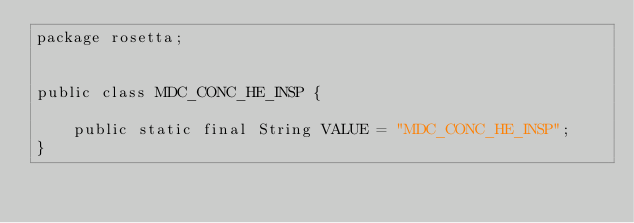<code> <loc_0><loc_0><loc_500><loc_500><_Java_>package rosetta;
        

public class MDC_CONC_HE_INSP {    
    
    public static final String VALUE = "MDC_CONC_HE_INSP";
}

</code> 